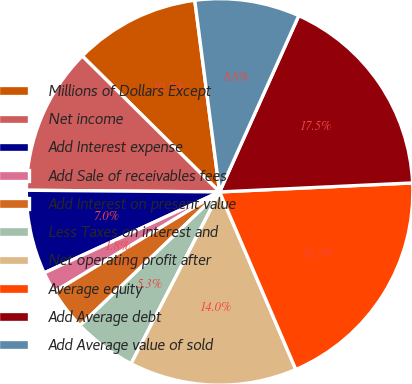Convert chart. <chart><loc_0><loc_0><loc_500><loc_500><pie_chart><fcel>Millions of Dollars Except<fcel>Net income<fcel>Add Interest expense<fcel>Add Sale of receivables fees<fcel>Add Interest on present value<fcel>Less Taxes on interest and<fcel>Net operating profit after<fcel>Average equity<fcel>Add Average debt<fcel>Add Average value of sold<nl><fcel>10.53%<fcel>12.28%<fcel>7.02%<fcel>1.76%<fcel>3.51%<fcel>5.27%<fcel>14.03%<fcel>19.29%<fcel>17.54%<fcel>8.77%<nl></chart> 